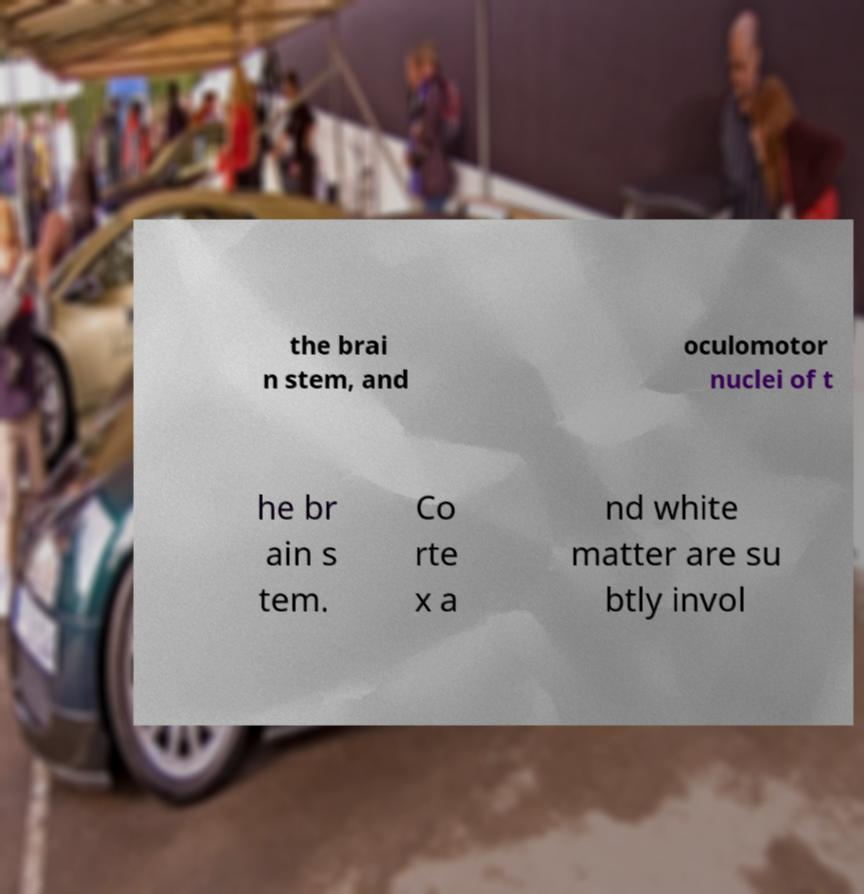What messages or text are displayed in this image? I need them in a readable, typed format. the brai n stem, and oculomotor nuclei of t he br ain s tem. Co rte x a nd white matter are su btly invol 